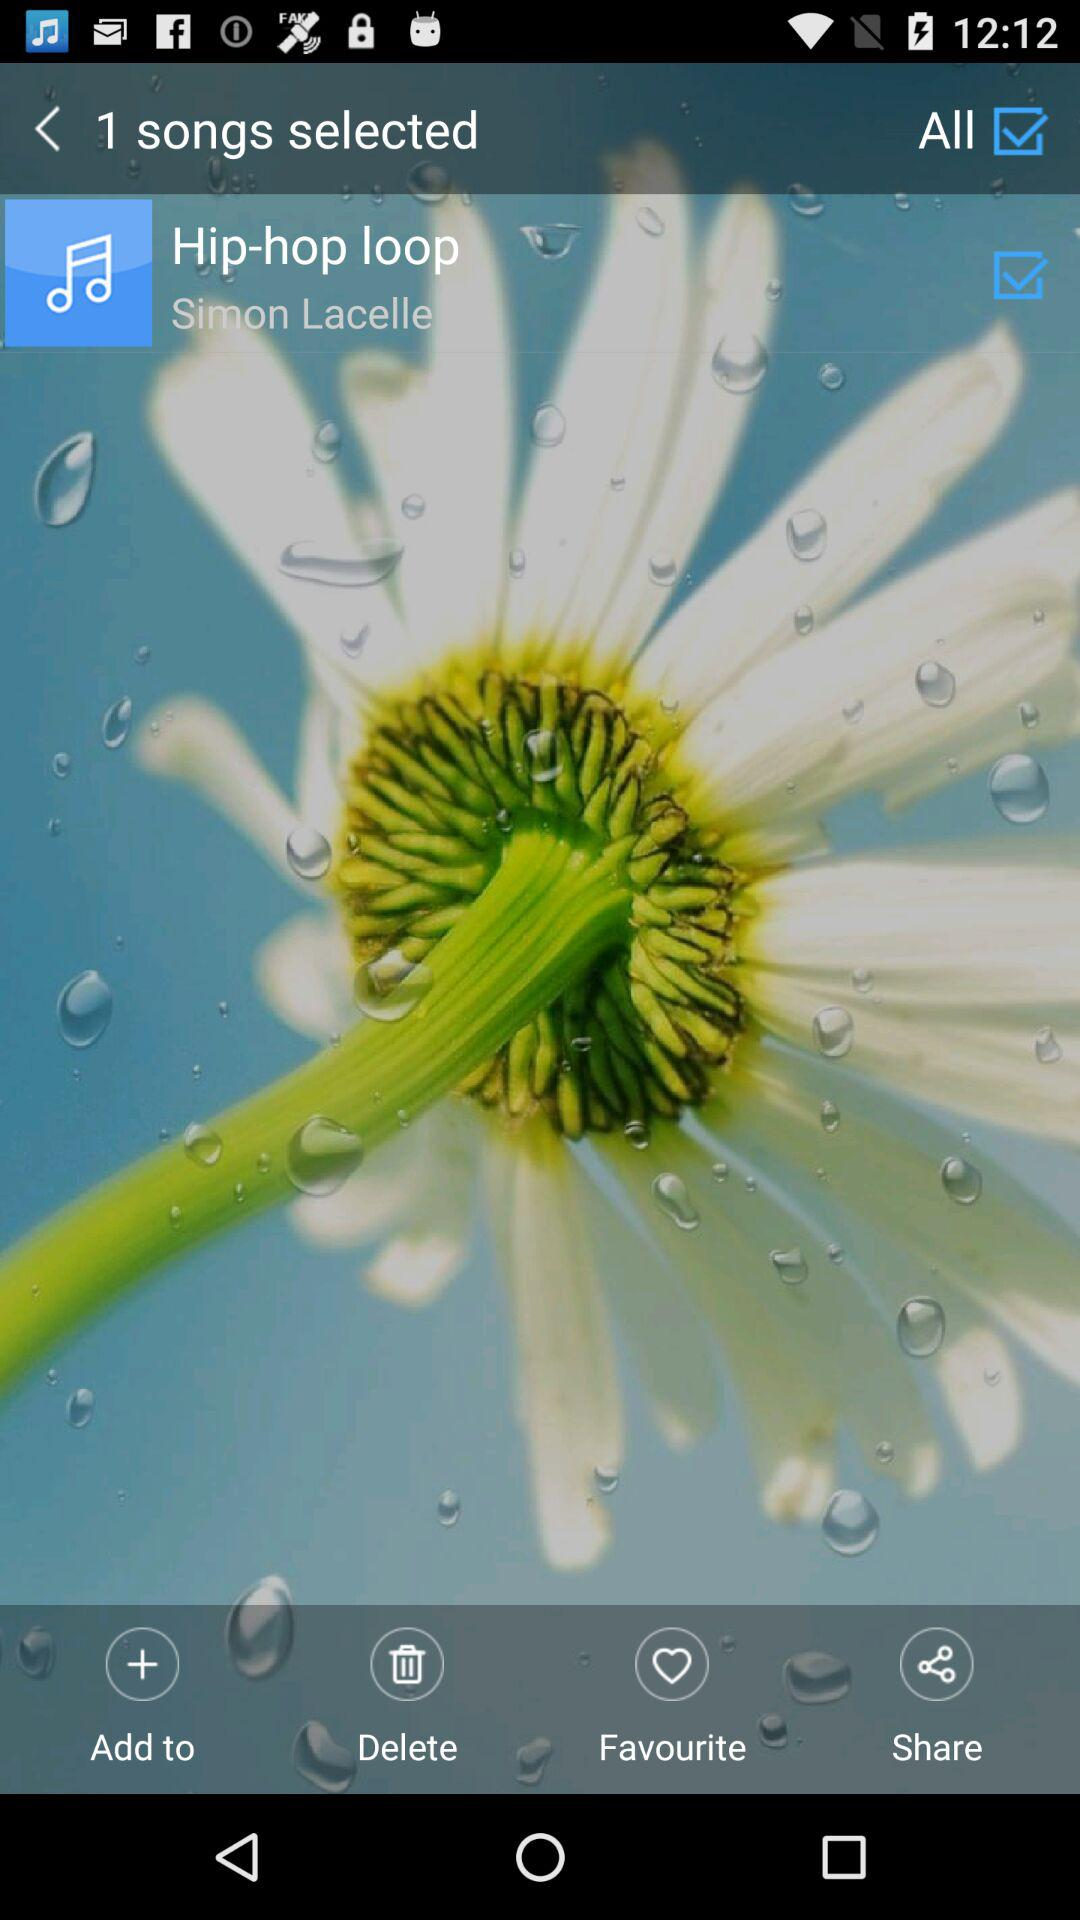How many songs are selected?
Answer the question using a single word or phrase. 1 